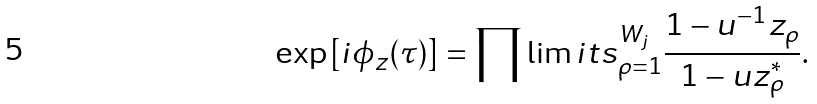Convert formula to latex. <formula><loc_0><loc_0><loc_500><loc_500>\exp \left [ i \phi _ { z } ( \tau ) \right ] = \prod \lim i t s _ { \rho = 1 } ^ { W _ { j } } \frac { 1 - u ^ { - 1 } z _ { \rho } } { 1 - u z _ { \rho } ^ { * } } .</formula> 